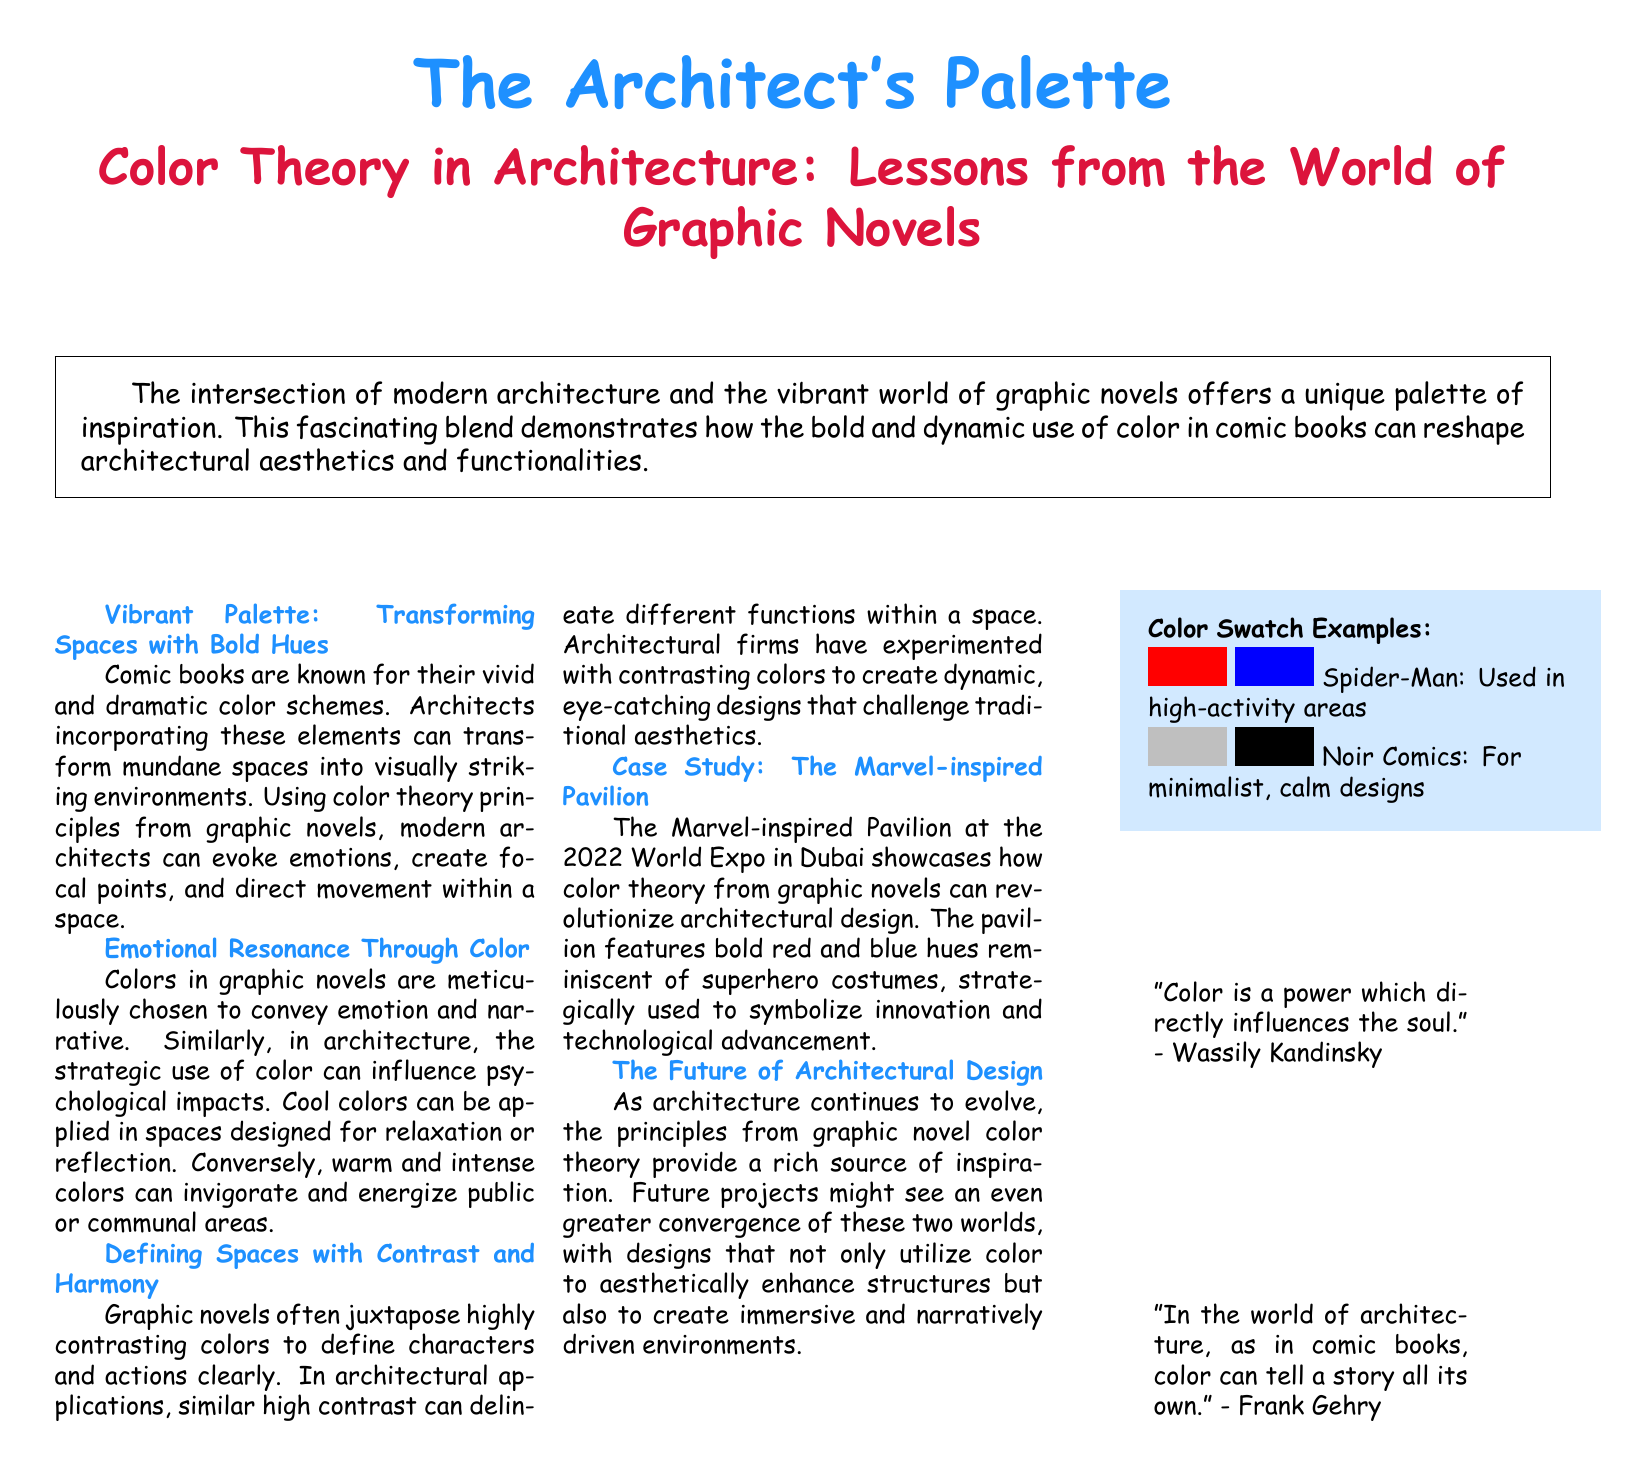What is the title of the document? The title of the document is prominently displayed at the top, which is "Color Theory in Architecture: Lessons from the World of Graphic Novels."
Answer: Color Theory in Architecture: Lessons from the World of Graphic Novels What unique font is used in the document? The document mentions that the main font used is "Comic Sans MS."
Answer: Comic Sans MS What does the mural in the future designs potentially utilize? The document suggests that future architectural designs might use "color to aesthetically enhance structures."
Answer: Color What color combinations are used in the Marvel-inspired Pavilion? The document states that the pavilion features "bold red and blue hues."
Answer: Bold red and blue hues Who is quoted saying, "Color is a power which directly influences the soul"? The quote is attributed to Wassily Kandinsky in the document.
Answer: Wassily Kandinsky How many columns are used in the main content of the document? The main content is presented in three columns, as indicated in the code.
Answer: Three columns What psychological effect can cool colors have according to the document? Cool colors are stated to be applied in spaces designed for "relaxation or reflection."
Answer: Relaxation or reflection What is a key purpose of using contrasting colors in architecture? The document notes that contrasting colors can "delineate different functions within a space."
Answer: Delineate different functions 